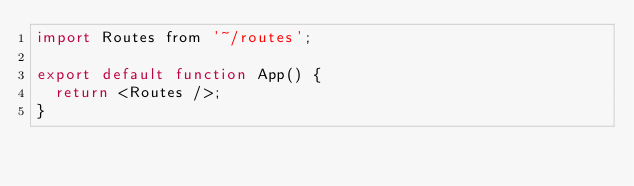<code> <loc_0><loc_0><loc_500><loc_500><_JavaScript_>import Routes from '~/routes';

export default function App() {
  return <Routes />;
}
</code> 